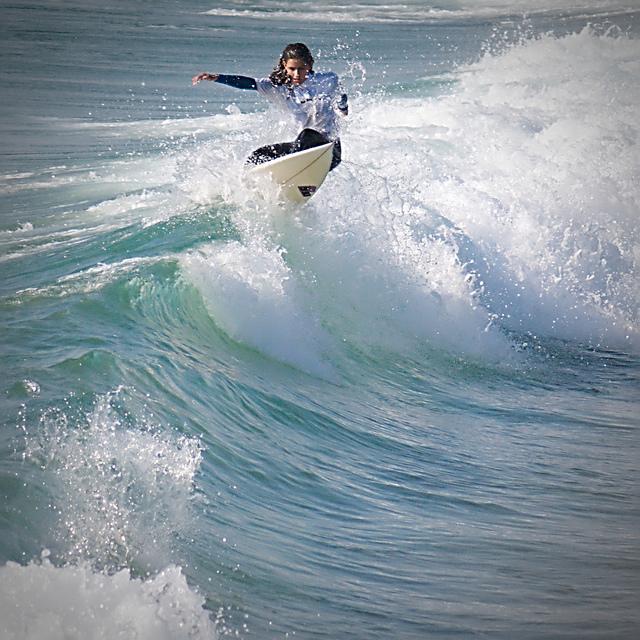What is this person doing?
Short answer required. Surfing. Is this a man or woman?
Write a very short answer. Woman. Is the woman wet?
Write a very short answer. Yes. How does the water look?
Be succinct. Blue. 